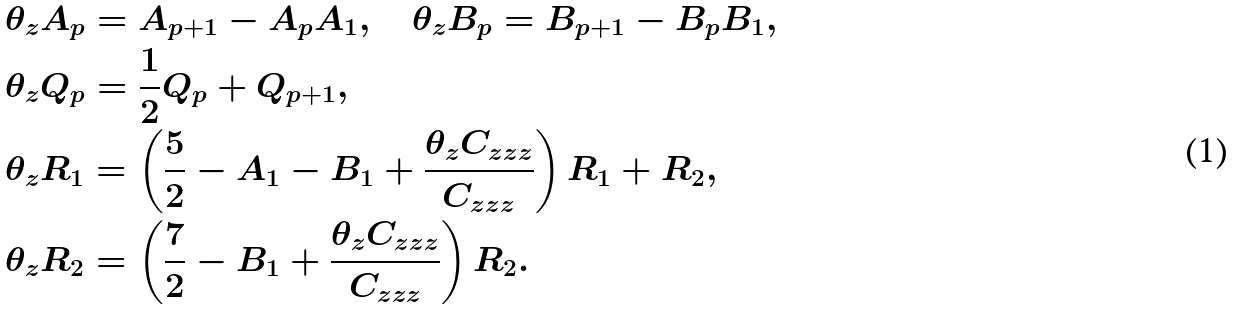<formula> <loc_0><loc_0><loc_500><loc_500>& \theta _ { z } A _ { p } = A _ { p + 1 } - A _ { p } A _ { 1 } , \quad \theta _ { z } B _ { p } = B _ { p + 1 } - B _ { p } B _ { 1 } , \\ & \theta _ { z } Q _ { p } = \frac { 1 } { 2 } Q _ { p } + Q _ { p + 1 } , \\ & \theta _ { z } R _ { 1 } = \left ( \frac { 5 } { 2 } - A _ { 1 } - B _ { 1 } + \frac { \theta _ { z } C _ { z z z } } { C _ { z z z } } \right ) R _ { 1 } + R _ { 2 } , \\ & \theta _ { z } R _ { 2 } = \left ( \frac { 7 } { 2 } - B _ { 1 } + \frac { \theta _ { z } C _ { z z z } } { C _ { z z z } } \right ) R _ { 2 } .</formula> 